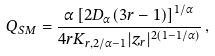Convert formula to latex. <formula><loc_0><loc_0><loc_500><loc_500>Q _ { S M } = \frac { \alpha \left [ 2 D _ { \alpha } ( 3 r - 1 ) \right ] ^ { 1 / \alpha } } { 4 r K _ { r , 2 / \alpha - 1 } | z _ { r } | ^ { 2 ( 1 - 1 / \alpha ) } } \, ,</formula> 